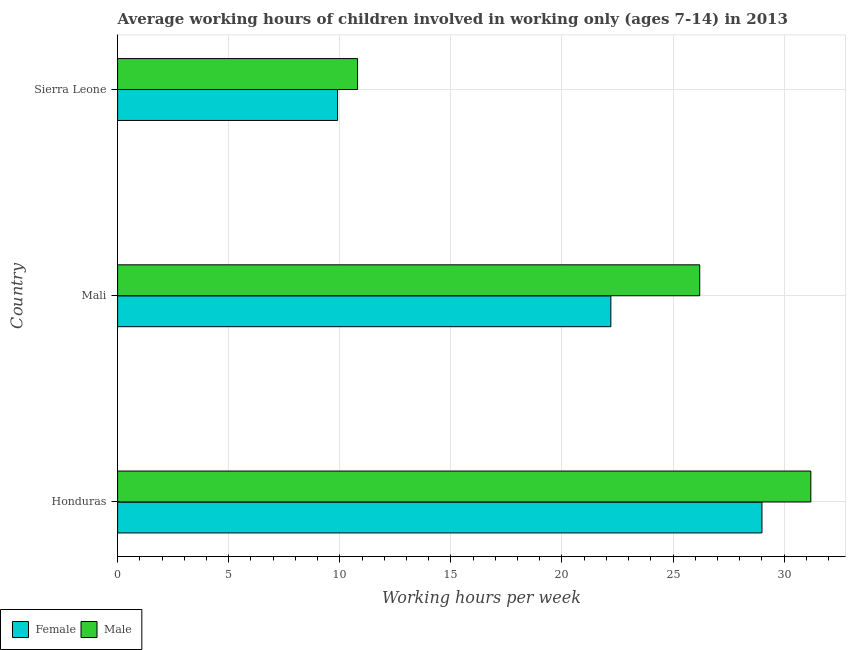How many different coloured bars are there?
Make the answer very short. 2. Are the number of bars on each tick of the Y-axis equal?
Provide a succinct answer. Yes. What is the label of the 3rd group of bars from the top?
Ensure brevity in your answer.  Honduras. In how many cases, is the number of bars for a given country not equal to the number of legend labels?
Keep it short and to the point. 0. Across all countries, what is the maximum average working hour of male children?
Ensure brevity in your answer.  31.2. In which country was the average working hour of female children maximum?
Offer a very short reply. Honduras. In which country was the average working hour of female children minimum?
Provide a short and direct response. Sierra Leone. What is the total average working hour of male children in the graph?
Keep it short and to the point. 68.2. What is the difference between the average working hour of male children in Honduras and the average working hour of female children in Sierra Leone?
Your answer should be very brief. 21.3. What is the average average working hour of male children per country?
Offer a very short reply. 22.73. What is the ratio of the average working hour of male children in Mali to that in Sierra Leone?
Offer a very short reply. 2.43. What is the difference between the highest and the lowest average working hour of male children?
Make the answer very short. 20.4. Is the sum of the average working hour of male children in Honduras and Mali greater than the maximum average working hour of female children across all countries?
Make the answer very short. Yes. What does the 2nd bar from the top in Honduras represents?
Ensure brevity in your answer.  Female. Are all the bars in the graph horizontal?
Provide a short and direct response. Yes. Are the values on the major ticks of X-axis written in scientific E-notation?
Offer a very short reply. No. Does the graph contain any zero values?
Your answer should be compact. No. Does the graph contain grids?
Your answer should be compact. Yes. What is the title of the graph?
Make the answer very short. Average working hours of children involved in working only (ages 7-14) in 2013. Does "Researchers" appear as one of the legend labels in the graph?
Offer a terse response. No. What is the label or title of the X-axis?
Ensure brevity in your answer.  Working hours per week. What is the label or title of the Y-axis?
Your answer should be very brief. Country. What is the Working hours per week in Male in Honduras?
Your answer should be very brief. 31.2. What is the Working hours per week in Male in Mali?
Offer a terse response. 26.2. What is the Working hours per week in Male in Sierra Leone?
Your answer should be compact. 10.8. Across all countries, what is the maximum Working hours per week of Male?
Offer a terse response. 31.2. Across all countries, what is the minimum Working hours per week of Female?
Offer a very short reply. 9.9. What is the total Working hours per week in Female in the graph?
Ensure brevity in your answer.  61.1. What is the total Working hours per week in Male in the graph?
Ensure brevity in your answer.  68.2. What is the difference between the Working hours per week of Female in Honduras and that in Mali?
Offer a very short reply. 6.8. What is the difference between the Working hours per week of Female in Honduras and that in Sierra Leone?
Your answer should be compact. 19.1. What is the difference between the Working hours per week in Male in Honduras and that in Sierra Leone?
Your response must be concise. 20.4. What is the difference between the Working hours per week in Female in Mali and that in Sierra Leone?
Give a very brief answer. 12.3. What is the difference between the Working hours per week in Male in Mali and that in Sierra Leone?
Your response must be concise. 15.4. What is the average Working hours per week in Female per country?
Give a very brief answer. 20.37. What is the average Working hours per week in Male per country?
Keep it short and to the point. 22.73. What is the difference between the Working hours per week of Female and Working hours per week of Male in Honduras?
Your response must be concise. -2.2. What is the ratio of the Working hours per week in Female in Honduras to that in Mali?
Give a very brief answer. 1.31. What is the ratio of the Working hours per week of Male in Honduras to that in Mali?
Ensure brevity in your answer.  1.19. What is the ratio of the Working hours per week of Female in Honduras to that in Sierra Leone?
Offer a very short reply. 2.93. What is the ratio of the Working hours per week of Male in Honduras to that in Sierra Leone?
Your answer should be compact. 2.89. What is the ratio of the Working hours per week in Female in Mali to that in Sierra Leone?
Keep it short and to the point. 2.24. What is the ratio of the Working hours per week of Male in Mali to that in Sierra Leone?
Your response must be concise. 2.43. What is the difference between the highest and the lowest Working hours per week of Female?
Your answer should be compact. 19.1. What is the difference between the highest and the lowest Working hours per week in Male?
Make the answer very short. 20.4. 